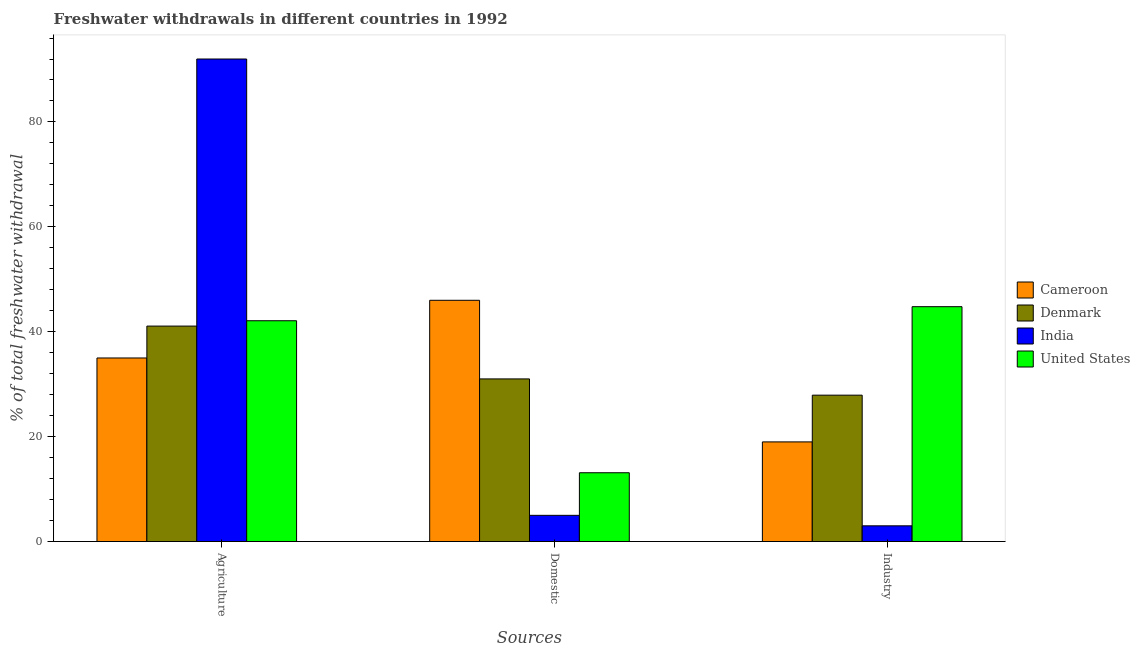How many different coloured bars are there?
Your response must be concise. 4. How many bars are there on the 2nd tick from the left?
Give a very brief answer. 4. How many bars are there on the 3rd tick from the right?
Give a very brief answer. 4. What is the label of the 2nd group of bars from the left?
Offer a terse response. Domestic. In which country was the percentage of freshwater withdrawal for agriculture maximum?
Keep it short and to the point. India. In which country was the percentage of freshwater withdrawal for agriculture minimum?
Provide a short and direct response. Cameroon. What is the total percentage of freshwater withdrawal for agriculture in the graph?
Offer a terse response. 210.18. What is the difference between the percentage of freshwater withdrawal for industry in United States and that in India?
Your answer should be compact. 41.78. What is the difference between the percentage of freshwater withdrawal for industry in United States and the percentage of freshwater withdrawal for domestic purposes in Denmark?
Offer a terse response. 13.77. What is the average percentage of freshwater withdrawal for domestic purposes per country?
Keep it short and to the point. 23.78. What is the difference between the percentage of freshwater withdrawal for industry and percentage of freshwater withdrawal for domestic purposes in United States?
Offer a very short reply. 31.66. In how many countries, is the percentage of freshwater withdrawal for agriculture greater than 80 %?
Offer a very short reply. 1. What is the ratio of the percentage of freshwater withdrawal for industry in United States to that in Cameroon?
Offer a terse response. 2.36. Is the difference between the percentage of freshwater withdrawal for industry in United States and Denmark greater than the difference between the percentage of freshwater withdrawal for agriculture in United States and Denmark?
Make the answer very short. Yes. What is the difference between the highest and the second highest percentage of freshwater withdrawal for industry?
Offer a terse response. 16.87. In how many countries, is the percentage of freshwater withdrawal for domestic purposes greater than the average percentage of freshwater withdrawal for domestic purposes taken over all countries?
Your answer should be very brief. 2. What does the 1st bar from the left in Domestic represents?
Offer a very short reply. Cameroon. What does the 4th bar from the right in Domestic represents?
Your answer should be compact. Cameroon. How many bars are there?
Your answer should be very brief. 12. How many countries are there in the graph?
Keep it short and to the point. 4. Are the values on the major ticks of Y-axis written in scientific E-notation?
Make the answer very short. No. Where does the legend appear in the graph?
Provide a short and direct response. Center right. How are the legend labels stacked?
Offer a terse response. Vertical. What is the title of the graph?
Your answer should be compact. Freshwater withdrawals in different countries in 1992. Does "Vanuatu" appear as one of the legend labels in the graph?
Keep it short and to the point. No. What is the label or title of the X-axis?
Ensure brevity in your answer.  Sources. What is the label or title of the Y-axis?
Offer a very short reply. % of total freshwater withdrawal. What is the % of total freshwater withdrawal in Cameroon in Agriculture?
Provide a succinct answer. 35. What is the % of total freshwater withdrawal of Denmark in Agriculture?
Give a very brief answer. 41.08. What is the % of total freshwater withdrawal in India in Agriculture?
Give a very brief answer. 92. What is the % of total freshwater withdrawal of United States in Agriculture?
Provide a succinct answer. 42.1. What is the % of total freshwater withdrawal in Cameroon in Domestic?
Your answer should be compact. 46. What is the % of total freshwater withdrawal of Denmark in Domestic?
Make the answer very short. 31.01. What is the % of total freshwater withdrawal of United States in Domestic?
Provide a succinct answer. 13.12. What is the % of total freshwater withdrawal of Cameroon in Industry?
Provide a short and direct response. 19. What is the % of total freshwater withdrawal of Denmark in Industry?
Make the answer very short. 27.91. What is the % of total freshwater withdrawal of India in Industry?
Provide a succinct answer. 3. What is the % of total freshwater withdrawal in United States in Industry?
Make the answer very short. 44.78. Across all Sources, what is the maximum % of total freshwater withdrawal of Cameroon?
Ensure brevity in your answer.  46. Across all Sources, what is the maximum % of total freshwater withdrawal of Denmark?
Your answer should be very brief. 41.08. Across all Sources, what is the maximum % of total freshwater withdrawal of India?
Keep it short and to the point. 92. Across all Sources, what is the maximum % of total freshwater withdrawal in United States?
Offer a terse response. 44.78. Across all Sources, what is the minimum % of total freshwater withdrawal of Cameroon?
Give a very brief answer. 19. Across all Sources, what is the minimum % of total freshwater withdrawal of Denmark?
Keep it short and to the point. 27.91. Across all Sources, what is the minimum % of total freshwater withdrawal of India?
Offer a very short reply. 3. Across all Sources, what is the minimum % of total freshwater withdrawal in United States?
Provide a short and direct response. 13.12. What is the total % of total freshwater withdrawal of Cameroon in the graph?
Make the answer very short. 100. What is the total % of total freshwater withdrawal in India in the graph?
Provide a short and direct response. 100. What is the total % of total freshwater withdrawal in United States in the graph?
Keep it short and to the point. 100. What is the difference between the % of total freshwater withdrawal in Denmark in Agriculture and that in Domestic?
Your answer should be compact. 10.07. What is the difference between the % of total freshwater withdrawal in India in Agriculture and that in Domestic?
Make the answer very short. 87. What is the difference between the % of total freshwater withdrawal of United States in Agriculture and that in Domestic?
Your answer should be compact. 28.98. What is the difference between the % of total freshwater withdrawal of Cameroon in Agriculture and that in Industry?
Your answer should be compact. 16. What is the difference between the % of total freshwater withdrawal in Denmark in Agriculture and that in Industry?
Make the answer very short. 13.17. What is the difference between the % of total freshwater withdrawal in India in Agriculture and that in Industry?
Your response must be concise. 89. What is the difference between the % of total freshwater withdrawal in United States in Agriculture and that in Industry?
Offer a terse response. -2.68. What is the difference between the % of total freshwater withdrawal in Denmark in Domestic and that in Industry?
Offer a very short reply. 3.1. What is the difference between the % of total freshwater withdrawal in United States in Domestic and that in Industry?
Your answer should be very brief. -31.66. What is the difference between the % of total freshwater withdrawal of Cameroon in Agriculture and the % of total freshwater withdrawal of Denmark in Domestic?
Offer a very short reply. 3.99. What is the difference between the % of total freshwater withdrawal of Cameroon in Agriculture and the % of total freshwater withdrawal of India in Domestic?
Keep it short and to the point. 30. What is the difference between the % of total freshwater withdrawal of Cameroon in Agriculture and the % of total freshwater withdrawal of United States in Domestic?
Offer a terse response. 21.88. What is the difference between the % of total freshwater withdrawal of Denmark in Agriculture and the % of total freshwater withdrawal of India in Domestic?
Keep it short and to the point. 36.08. What is the difference between the % of total freshwater withdrawal of Denmark in Agriculture and the % of total freshwater withdrawal of United States in Domestic?
Offer a very short reply. 27.96. What is the difference between the % of total freshwater withdrawal of India in Agriculture and the % of total freshwater withdrawal of United States in Domestic?
Offer a very short reply. 78.88. What is the difference between the % of total freshwater withdrawal of Cameroon in Agriculture and the % of total freshwater withdrawal of Denmark in Industry?
Offer a very short reply. 7.09. What is the difference between the % of total freshwater withdrawal in Cameroon in Agriculture and the % of total freshwater withdrawal in India in Industry?
Give a very brief answer. 32. What is the difference between the % of total freshwater withdrawal of Cameroon in Agriculture and the % of total freshwater withdrawal of United States in Industry?
Your response must be concise. -9.78. What is the difference between the % of total freshwater withdrawal in Denmark in Agriculture and the % of total freshwater withdrawal in India in Industry?
Your answer should be very brief. 38.08. What is the difference between the % of total freshwater withdrawal in India in Agriculture and the % of total freshwater withdrawal in United States in Industry?
Offer a very short reply. 47.22. What is the difference between the % of total freshwater withdrawal of Cameroon in Domestic and the % of total freshwater withdrawal of Denmark in Industry?
Your answer should be very brief. 18.09. What is the difference between the % of total freshwater withdrawal of Cameroon in Domestic and the % of total freshwater withdrawal of India in Industry?
Your response must be concise. 43. What is the difference between the % of total freshwater withdrawal of Cameroon in Domestic and the % of total freshwater withdrawal of United States in Industry?
Ensure brevity in your answer.  1.22. What is the difference between the % of total freshwater withdrawal in Denmark in Domestic and the % of total freshwater withdrawal in India in Industry?
Make the answer very short. 28.01. What is the difference between the % of total freshwater withdrawal in Denmark in Domestic and the % of total freshwater withdrawal in United States in Industry?
Your answer should be compact. -13.77. What is the difference between the % of total freshwater withdrawal in India in Domestic and the % of total freshwater withdrawal in United States in Industry?
Provide a succinct answer. -39.78. What is the average % of total freshwater withdrawal in Cameroon per Sources?
Your answer should be very brief. 33.33. What is the average % of total freshwater withdrawal of Denmark per Sources?
Your answer should be very brief. 33.33. What is the average % of total freshwater withdrawal of India per Sources?
Your response must be concise. 33.33. What is the average % of total freshwater withdrawal of United States per Sources?
Offer a terse response. 33.33. What is the difference between the % of total freshwater withdrawal of Cameroon and % of total freshwater withdrawal of Denmark in Agriculture?
Ensure brevity in your answer.  -6.08. What is the difference between the % of total freshwater withdrawal in Cameroon and % of total freshwater withdrawal in India in Agriculture?
Provide a short and direct response. -57. What is the difference between the % of total freshwater withdrawal in Denmark and % of total freshwater withdrawal in India in Agriculture?
Your answer should be very brief. -50.92. What is the difference between the % of total freshwater withdrawal in Denmark and % of total freshwater withdrawal in United States in Agriculture?
Your response must be concise. -1.02. What is the difference between the % of total freshwater withdrawal in India and % of total freshwater withdrawal in United States in Agriculture?
Provide a short and direct response. 49.9. What is the difference between the % of total freshwater withdrawal in Cameroon and % of total freshwater withdrawal in Denmark in Domestic?
Provide a short and direct response. 14.99. What is the difference between the % of total freshwater withdrawal of Cameroon and % of total freshwater withdrawal of India in Domestic?
Offer a terse response. 41. What is the difference between the % of total freshwater withdrawal of Cameroon and % of total freshwater withdrawal of United States in Domestic?
Offer a very short reply. 32.88. What is the difference between the % of total freshwater withdrawal in Denmark and % of total freshwater withdrawal in India in Domestic?
Provide a succinct answer. 26.01. What is the difference between the % of total freshwater withdrawal in Denmark and % of total freshwater withdrawal in United States in Domestic?
Make the answer very short. 17.89. What is the difference between the % of total freshwater withdrawal in India and % of total freshwater withdrawal in United States in Domestic?
Make the answer very short. -8.12. What is the difference between the % of total freshwater withdrawal of Cameroon and % of total freshwater withdrawal of Denmark in Industry?
Offer a very short reply. -8.91. What is the difference between the % of total freshwater withdrawal of Cameroon and % of total freshwater withdrawal of India in Industry?
Offer a terse response. 16. What is the difference between the % of total freshwater withdrawal in Cameroon and % of total freshwater withdrawal in United States in Industry?
Your response must be concise. -25.78. What is the difference between the % of total freshwater withdrawal of Denmark and % of total freshwater withdrawal of India in Industry?
Keep it short and to the point. 24.91. What is the difference between the % of total freshwater withdrawal of Denmark and % of total freshwater withdrawal of United States in Industry?
Ensure brevity in your answer.  -16.87. What is the difference between the % of total freshwater withdrawal in India and % of total freshwater withdrawal in United States in Industry?
Give a very brief answer. -41.78. What is the ratio of the % of total freshwater withdrawal of Cameroon in Agriculture to that in Domestic?
Make the answer very short. 0.76. What is the ratio of the % of total freshwater withdrawal of Denmark in Agriculture to that in Domestic?
Make the answer very short. 1.32. What is the ratio of the % of total freshwater withdrawal of United States in Agriculture to that in Domestic?
Provide a short and direct response. 3.21. What is the ratio of the % of total freshwater withdrawal in Cameroon in Agriculture to that in Industry?
Make the answer very short. 1.84. What is the ratio of the % of total freshwater withdrawal of Denmark in Agriculture to that in Industry?
Keep it short and to the point. 1.47. What is the ratio of the % of total freshwater withdrawal of India in Agriculture to that in Industry?
Make the answer very short. 30.67. What is the ratio of the % of total freshwater withdrawal in United States in Agriculture to that in Industry?
Make the answer very short. 0.94. What is the ratio of the % of total freshwater withdrawal in Cameroon in Domestic to that in Industry?
Your answer should be compact. 2.42. What is the ratio of the % of total freshwater withdrawal in United States in Domestic to that in Industry?
Your answer should be compact. 0.29. What is the difference between the highest and the second highest % of total freshwater withdrawal in Cameroon?
Your answer should be compact. 11. What is the difference between the highest and the second highest % of total freshwater withdrawal of Denmark?
Make the answer very short. 10.07. What is the difference between the highest and the second highest % of total freshwater withdrawal of India?
Your response must be concise. 87. What is the difference between the highest and the second highest % of total freshwater withdrawal in United States?
Offer a very short reply. 2.68. What is the difference between the highest and the lowest % of total freshwater withdrawal of Denmark?
Your answer should be compact. 13.17. What is the difference between the highest and the lowest % of total freshwater withdrawal of India?
Provide a short and direct response. 89. What is the difference between the highest and the lowest % of total freshwater withdrawal of United States?
Your answer should be compact. 31.66. 